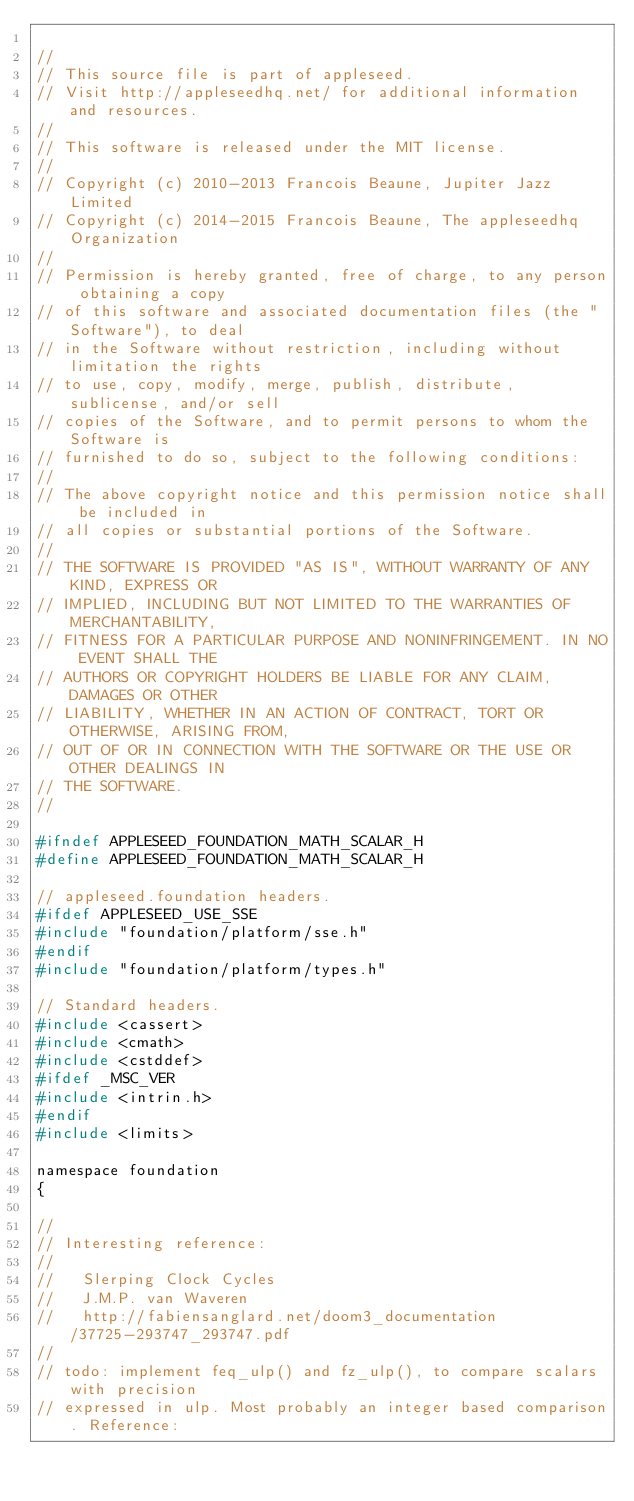<code> <loc_0><loc_0><loc_500><loc_500><_C_>
//
// This source file is part of appleseed.
// Visit http://appleseedhq.net/ for additional information and resources.
//
// This software is released under the MIT license.
//
// Copyright (c) 2010-2013 Francois Beaune, Jupiter Jazz Limited
// Copyright (c) 2014-2015 Francois Beaune, The appleseedhq Organization
//
// Permission is hereby granted, free of charge, to any person obtaining a copy
// of this software and associated documentation files (the "Software"), to deal
// in the Software without restriction, including without limitation the rights
// to use, copy, modify, merge, publish, distribute, sublicense, and/or sell
// copies of the Software, and to permit persons to whom the Software is
// furnished to do so, subject to the following conditions:
//
// The above copyright notice and this permission notice shall be included in
// all copies or substantial portions of the Software.
//
// THE SOFTWARE IS PROVIDED "AS IS", WITHOUT WARRANTY OF ANY KIND, EXPRESS OR
// IMPLIED, INCLUDING BUT NOT LIMITED TO THE WARRANTIES OF MERCHANTABILITY,
// FITNESS FOR A PARTICULAR PURPOSE AND NONINFRINGEMENT. IN NO EVENT SHALL THE
// AUTHORS OR COPYRIGHT HOLDERS BE LIABLE FOR ANY CLAIM, DAMAGES OR OTHER
// LIABILITY, WHETHER IN AN ACTION OF CONTRACT, TORT OR OTHERWISE, ARISING FROM,
// OUT OF OR IN CONNECTION WITH THE SOFTWARE OR THE USE OR OTHER DEALINGS IN
// THE SOFTWARE.
//

#ifndef APPLESEED_FOUNDATION_MATH_SCALAR_H
#define APPLESEED_FOUNDATION_MATH_SCALAR_H

// appleseed.foundation headers.
#ifdef APPLESEED_USE_SSE
#include "foundation/platform/sse.h"
#endif
#include "foundation/platform/types.h"

// Standard headers.
#include <cassert>
#include <cmath>
#include <cstddef>
#ifdef _MSC_VER
#include <intrin.h>
#endif
#include <limits>

namespace foundation
{

//
// Interesting reference:
//
//   Slerping Clock Cycles
//   J.M.P. van Waveren
//   http://fabiensanglard.net/doom3_documentation/37725-293747_293747.pdf
//
// todo: implement feq_ulp() and fz_ulp(), to compare scalars with precision
// expressed in ulp. Most probably an integer based comparison. Reference:</code> 